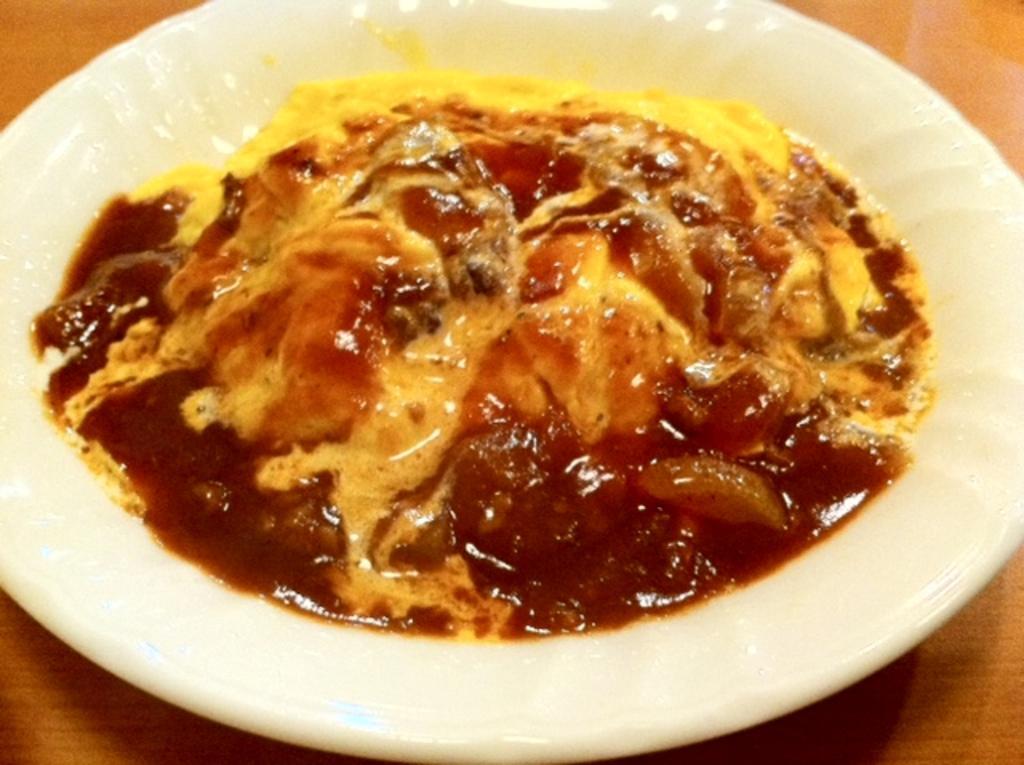Can you describe this image briefly? In this, we can see some food item on a plate is placed on the surface. 